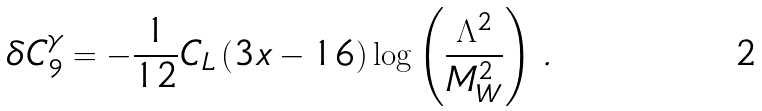Convert formula to latex. <formula><loc_0><loc_0><loc_500><loc_500>\delta C _ { 9 } ^ { \gamma } = - \frac { 1 } { 1 2 } C _ { L } \, ( 3 x - 1 6 ) \log \left ( \frac { \Lambda ^ { 2 } } { M _ { W } ^ { 2 } } \right ) \, .</formula> 